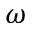Convert formula to latex. <formula><loc_0><loc_0><loc_500><loc_500>\omega</formula> 